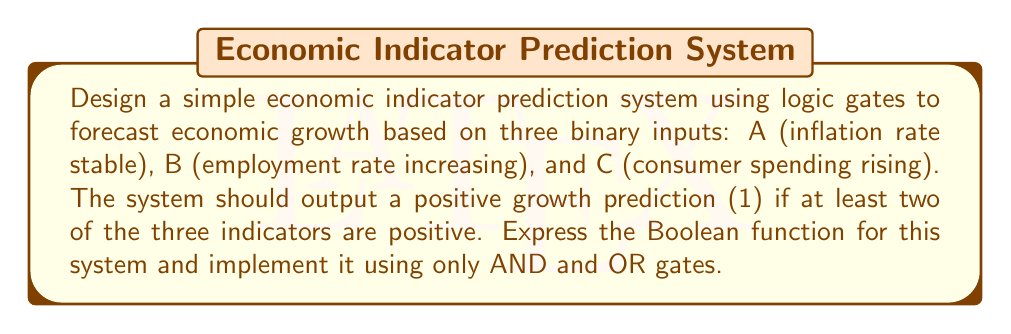Can you solve this math problem? Let's approach this step-by-step:

1) First, we need to define our Boolean function. We want the output to be 1 (positive growth) if at least two of the three inputs are 1. This can be expressed as:

   $$ F = AB + AC + BC $$

   Where '+' represents OR, and juxtaposition represents AND.

2) To implement this using only AND and OR gates, we can directly translate the Boolean expression:

   - We need three AND gates to compute AB, AC, and BC
   - We then need two OR gates to combine these results

3) The implementation would look like this:

   [asy]
   import geometry;

   pair A = (0,100), B = (0,60), C = (0,20);
   pair AND1 = (100,80), AND2 = (100,40), AND3 = (100,0);
   pair OR1 = (200,60), OR2 = (300,30);

   draw(A--AND1--OR1--OR2, arrow=Arrow(TeXHead));
   draw(B--AND1, arrow=Arrow(TeXHead));
   draw(B--AND2--OR1, arrow=Arrow(TeXHead));
   draw(C--AND2, arrow=Arrow(TeXHead));
   draw(C--AND3--OR2, arrow=Arrow(TeXHead));
   draw(A--AND3, arrow=Arrow(TeXHead));

   label("A", A, W);
   label("B", B, W);
   label("C", C, W);
   label("AND", AND1, E);
   label("AND", AND2, E);
   label("AND", AND3, E);
   label("OR", OR1, E);
   label("OR", OR2, E);
   label("F", (320,30), E);
   [/asy]

4) This implementation directly computes the Boolean function we defined, providing a positive growth prediction (output 1) when at least two of the three economic indicators are positive.
Answer: $F = AB + AC + BC$ 